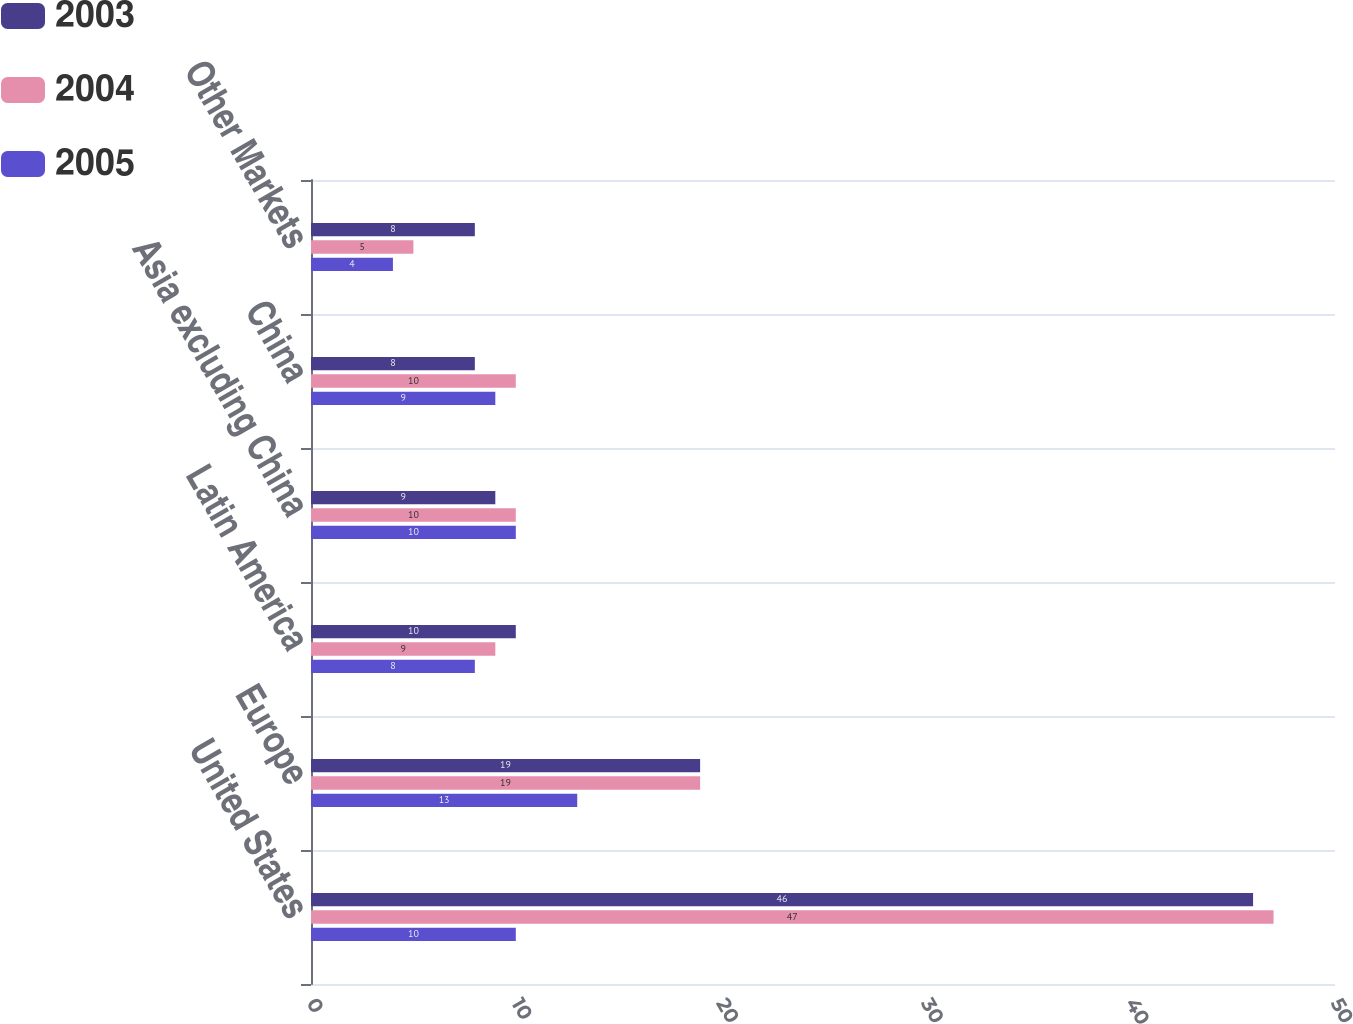Convert chart to OTSL. <chart><loc_0><loc_0><loc_500><loc_500><stacked_bar_chart><ecel><fcel>United States<fcel>Europe<fcel>Latin America<fcel>Asia excluding China<fcel>China<fcel>Other Markets<nl><fcel>2003<fcel>46<fcel>19<fcel>10<fcel>9<fcel>8<fcel>8<nl><fcel>2004<fcel>47<fcel>19<fcel>9<fcel>10<fcel>10<fcel>5<nl><fcel>2005<fcel>10<fcel>13<fcel>8<fcel>10<fcel>9<fcel>4<nl></chart> 